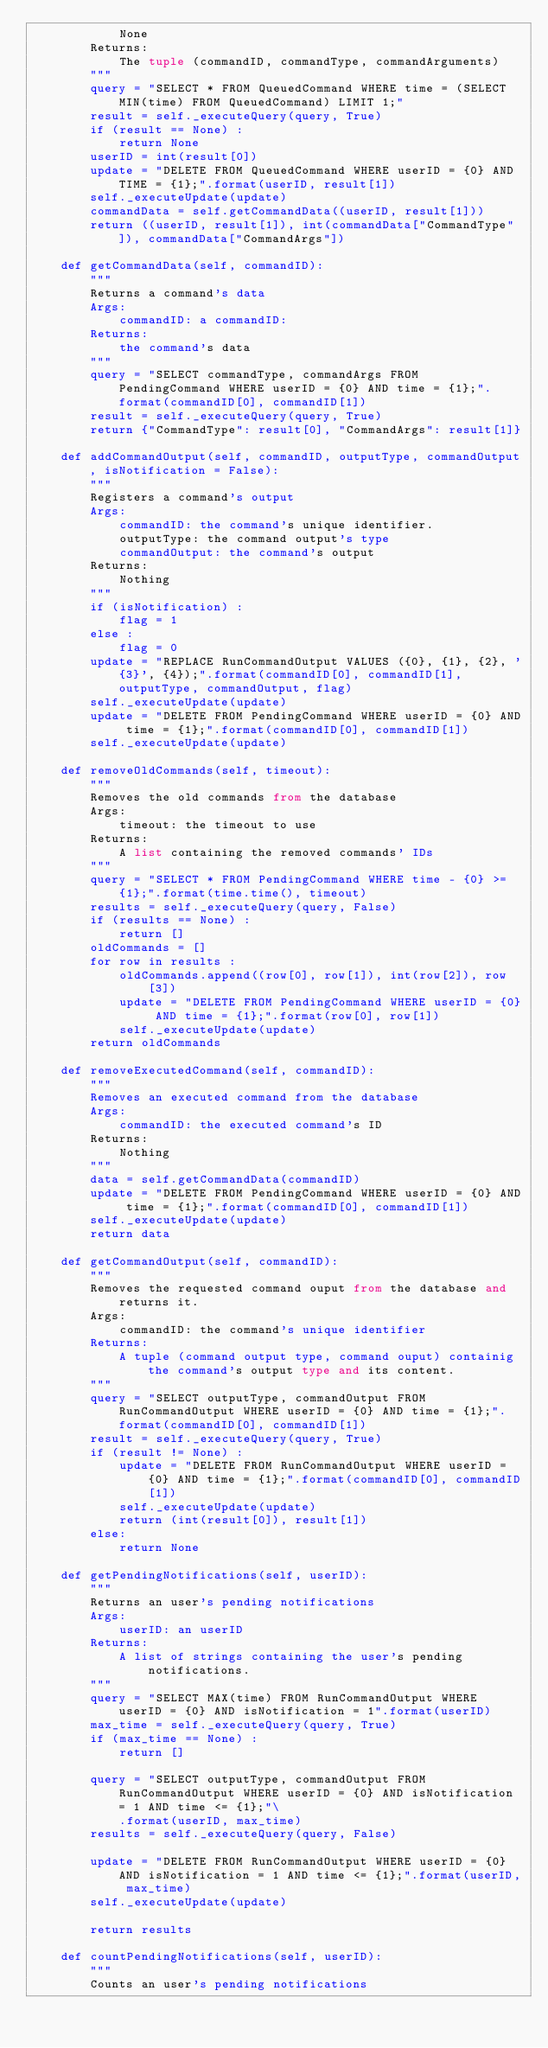Convert code to text. <code><loc_0><loc_0><loc_500><loc_500><_Python_>            None
        Returns:
            The tuple (commandID, commandType, commandArguments)
        """
        query = "SELECT * FROM QueuedCommand WHERE time = (SELECT MIN(time) FROM QueuedCommand) LIMIT 1;"
        result = self._executeQuery(query, True)
        if (result == None) :
            return None     
        userID = int(result[0])
        update = "DELETE FROM QueuedCommand WHERE userID = {0} AND TIME = {1};".format(userID, result[1])
        self._executeUpdate(update)
        commandData = self.getCommandData((userID, result[1]))
        return ((userID, result[1]), int(commandData["CommandType"]), commandData["CommandArgs"])
    
    def getCommandData(self, commandID):
        """
        Returns a command's data
        Args:
            commandID: a commandID:
        Returns:
            the command's data
        """
        query = "SELECT commandType, commandArgs FROM PendingCommand WHERE userID = {0} AND time = {1};".format(commandID[0], commandID[1])
        result = self._executeQuery(query, True)     
        return {"CommandType": result[0], "CommandArgs": result[1]}   
    
    def addCommandOutput(self, commandID, outputType, commandOutput, isNotification = False):
        """
        Registers a command's output
        Args:
            commandID: the command's unique identifier.
            outputType: the command output's type
            commandOutput: the command's output
        Returns:
            Nothing
        """
        if (isNotification) :
            flag = 1
        else :
            flag = 0
        update = "REPLACE RunCommandOutput VALUES ({0}, {1}, {2}, '{3}', {4});".format(commandID[0], commandID[1], outputType, commandOutput, flag)
        self._executeUpdate(update)
        update = "DELETE FROM PendingCommand WHERE userID = {0} AND time = {1};".format(commandID[0], commandID[1])
        self._executeUpdate(update)
        
    def removeOldCommands(self, timeout):     
        """
        Removes the old commands from the database
        Args:
            timeout: the timeout to use
        Returns:
            A list containing the removed commands' IDs
        """   
        query = "SELECT * FROM PendingCommand WHERE time - {0} >= {1};".format(time.time(), timeout)
        results = self._executeQuery(query, False)
        if (results == None) :
            return []
        oldCommands = []
        for row in results :
            oldCommands.append((row[0], row[1]), int(row[2]), row[3])
            update = "DELETE FROM PendingCommand WHERE userID = {0} AND time = {1};".format(row[0], row[1])
            self._executeUpdate(update)
        return oldCommands        
        
    def removeExecutedCommand(self, commandID):
        """
        Removes an executed command from the database
        Args:
            commandID: the executed command's ID
        Returns:
            Nothing
        """
        data = self.getCommandData(commandID)
        update = "DELETE FROM PendingCommand WHERE userID = {0} AND time = {1};".format(commandID[0], commandID[1])
        self._executeUpdate(update)
        return data
            
    def getCommandOutput(self, commandID):
        """
        Removes the requested command ouput from the database and returns it.
        Args:
            commandID: the command's unique identifier
        Returns:
            A tuple (command output type, command ouput) containig the command's output type and its content.
        """
        query = "SELECT outputType, commandOutput FROM RunCommandOutput WHERE userID = {0} AND time = {1};".format(commandID[0], commandID[1])
        result = self._executeQuery(query, True)
        if (result != None) :
            update = "DELETE FROM RunCommandOutput WHERE userID = {0} AND time = {1};".format(commandID[0], commandID[1])
            self._executeUpdate(update)
            return (int(result[0]), result[1])
        else:
            return None
        
    def getPendingNotifications(self, userID):
        """
        Returns an user's pending notifications
        Args:
            userID: an userID
        Returns:
            A list of strings containing the user's pending notifications.
        """
        query = "SELECT MAX(time) FROM RunCommandOutput WHERE userID = {0} AND isNotification = 1".format(userID)
        max_time = self._executeQuery(query, True)
        if (max_time == None) :
            return []
        
        query = "SELECT outputType, commandOutput FROM RunCommandOutput WHERE userID = {0} AND isNotification = 1 AND time <= {1};"\
            .format(userID, max_time)
        results = self._executeQuery(query, False)
           
        update = "DELETE FROM RunCommandOutput WHERE userID = {0} AND isNotification = 1 AND time <= {1};".format(userID, max_time)
        self._executeUpdate(update)
            
        return results
    
    def countPendingNotifications(self, userID):
        """
        Counts an user's pending notifications</code> 